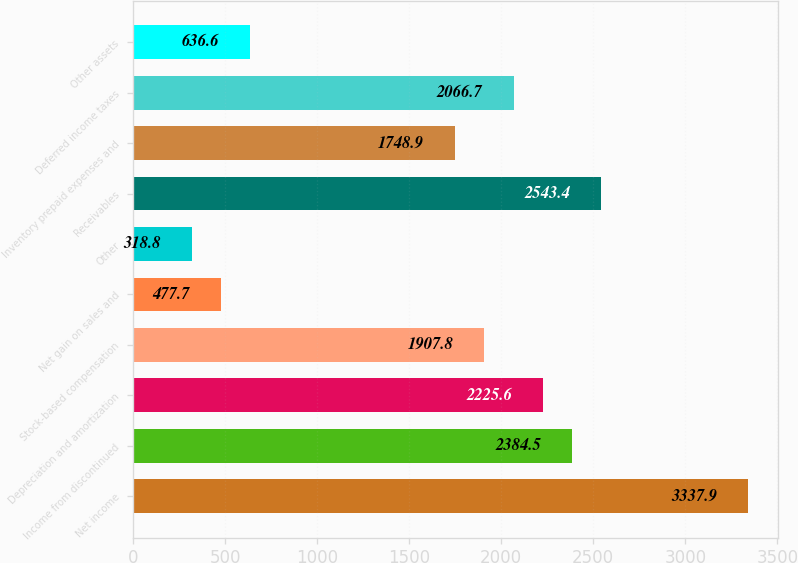<chart> <loc_0><loc_0><loc_500><loc_500><bar_chart><fcel>Net income<fcel>Income from discontinued<fcel>Depreciation and amortization<fcel>Stock-based compensation<fcel>Net gain on sales and<fcel>Other<fcel>Receivables<fcel>Inventory prepaid expenses and<fcel>Deferred income taxes<fcel>Other assets<nl><fcel>3337.9<fcel>2384.5<fcel>2225.6<fcel>1907.8<fcel>477.7<fcel>318.8<fcel>2543.4<fcel>1748.9<fcel>2066.7<fcel>636.6<nl></chart> 